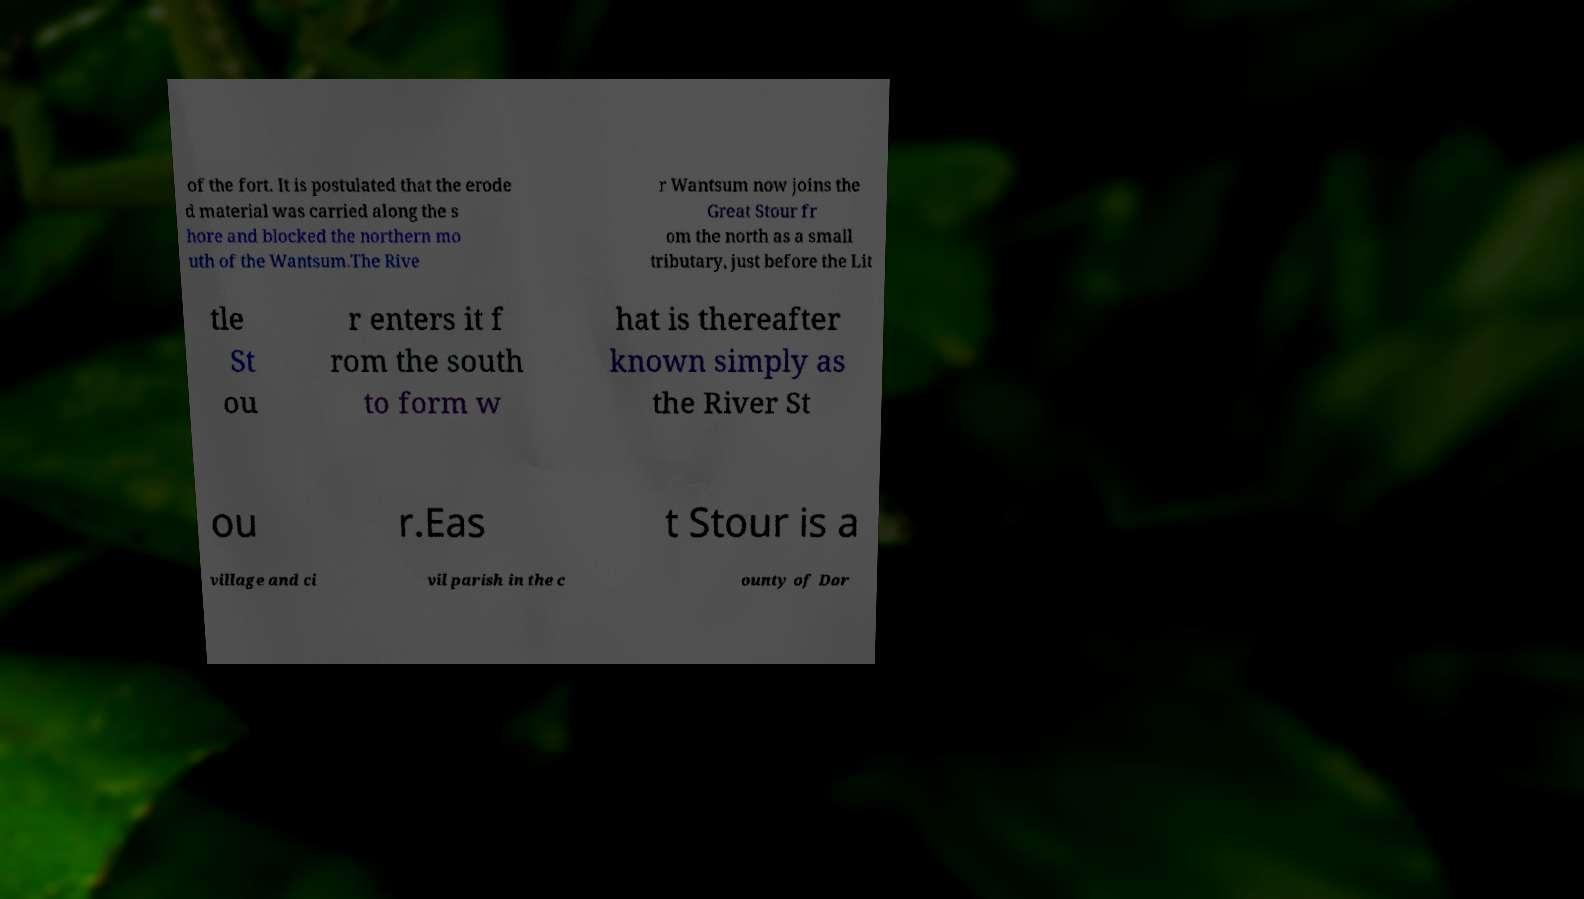Please read and relay the text visible in this image. What does it say? of the fort. It is postulated that the erode d material was carried along the s hore and blocked the northern mo uth of the Wantsum.The Rive r Wantsum now joins the Great Stour fr om the north as a small tributary, just before the Lit tle St ou r enters it f rom the south to form w hat is thereafter known simply as the River St ou r.Eas t Stour is a village and ci vil parish in the c ounty of Dor 